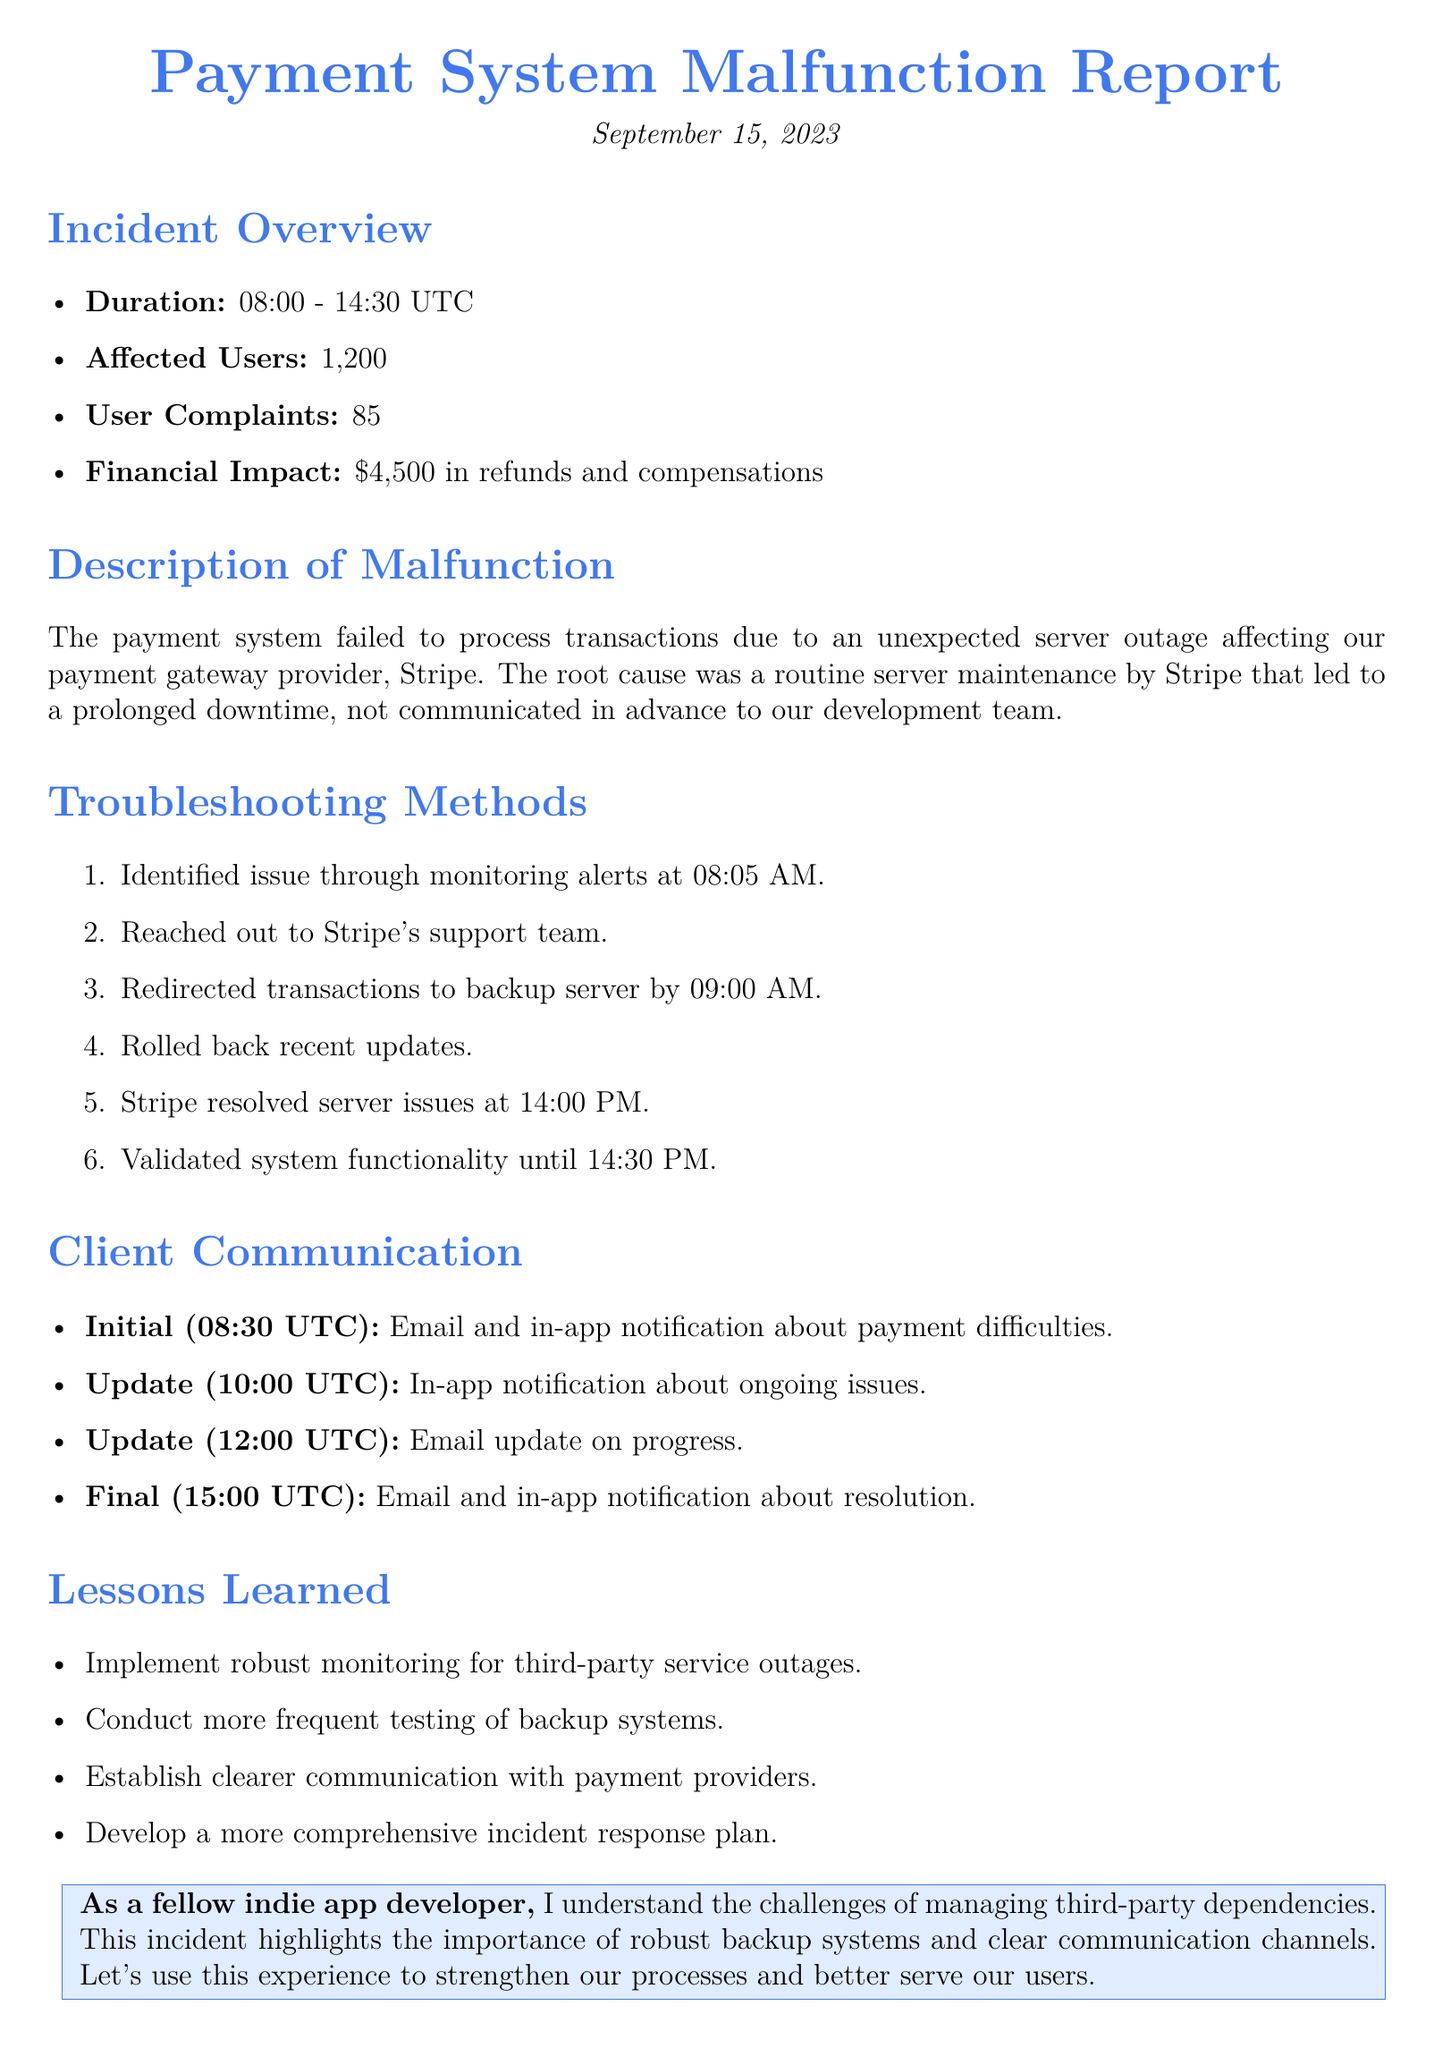What was the duration of the incident? The duration is noted in the incident overview section, indicating that it started at 08:00 and ended at 14:30 UTC.
Answer: 08:00 - 14:30 UTC How many users were affected? The number of affected users is listed in the incident overview.
Answer: 1,200 What was the financial impact of the malfunction? The financial impact is described in the overview as refunds and compensations totaling a specific amount.
Answer: $4,500 What was the root cause of the payment system failure? The root cause is detailed in the description of the malfunction regarding server maintenance by a specific provider.
Answer: Routine server maintenance by Stripe At what time was the first client communication sent? The initial communication time is specified in the client communication section.
Answer: 08:30 UTC What action was taken at 09:00 AM? The troubleshooting methods describe the action taken at this specific time.
Answer: Redirected transactions to backup server What is one lesson learned from this incident? The lessons learned section lists the takeaways from the incident.
Answer: Implement robust monitoring for third-party service outages How many user complaints were reported? The number of user complaints is provided in the incident overview.
Answer: 85 What was the final client communication time? The final communication time is noted in the client communication section.
Answer: 15:00 UTC 